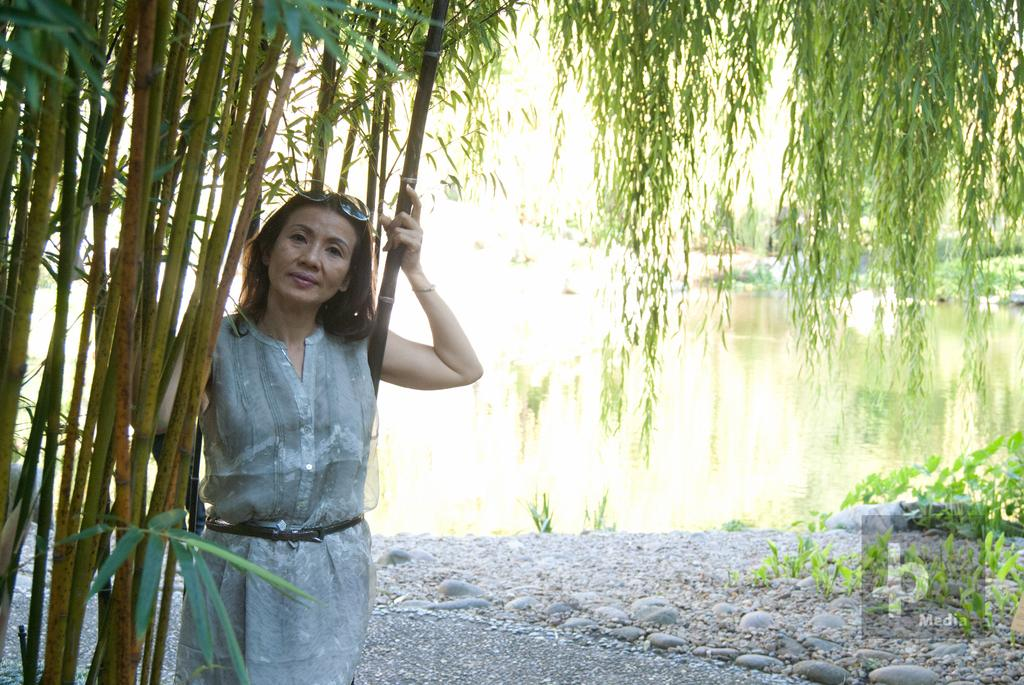What is the main subject of the image? There is a lady person in the image. What is the lady person wearing? The lady person is wearing a white dress and goggles. Where is the lady person standing in relation to the tree? The lady person is standing near a tree. What can be seen in the background of the image? There are trees and water visible in the background of the image. What type of receipt can be seen in the lady person's hand in the image? There is no receipt visible in the lady person's hand or anywhere in the image. 